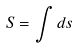Convert formula to latex. <formula><loc_0><loc_0><loc_500><loc_500>S = \int d s</formula> 